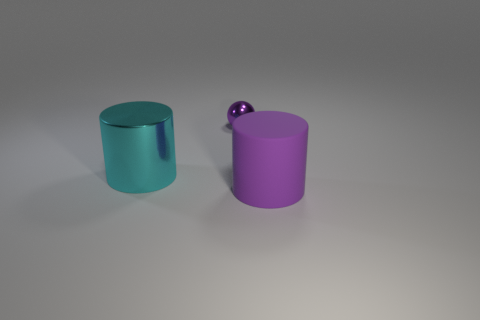What is the shape of the large matte thing that is the same color as the tiny sphere? cylinder 